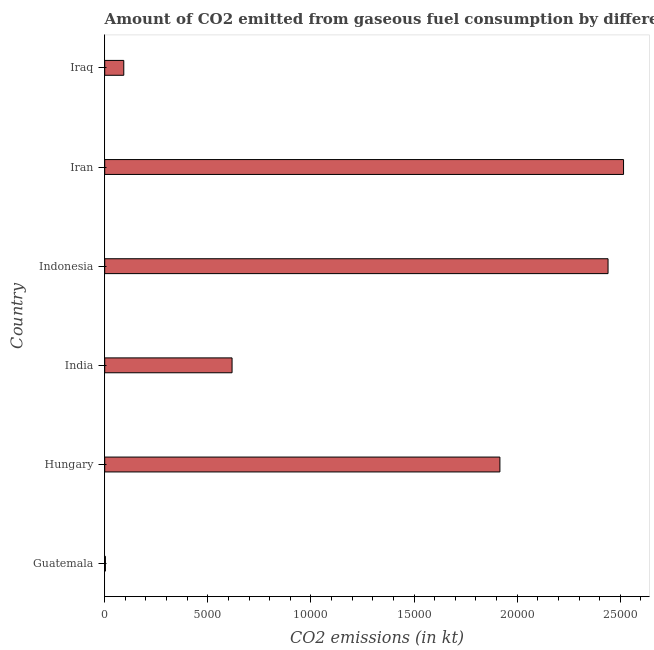Does the graph contain grids?
Provide a short and direct response. No. What is the title of the graph?
Make the answer very short. Amount of CO2 emitted from gaseous fuel consumption by different countries in 1984. What is the label or title of the X-axis?
Offer a very short reply. CO2 emissions (in kt). What is the label or title of the Y-axis?
Your answer should be compact. Country. What is the co2 emissions from gaseous fuel consumption in India?
Your answer should be compact. 6175.23. Across all countries, what is the maximum co2 emissions from gaseous fuel consumption?
Make the answer very short. 2.52e+04. Across all countries, what is the minimum co2 emissions from gaseous fuel consumption?
Keep it short and to the point. 33. In which country was the co2 emissions from gaseous fuel consumption maximum?
Your answer should be very brief. Iran. In which country was the co2 emissions from gaseous fuel consumption minimum?
Ensure brevity in your answer.  Guatemala. What is the sum of the co2 emissions from gaseous fuel consumption?
Provide a succinct answer. 7.59e+04. What is the difference between the co2 emissions from gaseous fuel consumption in Indonesia and Iraq?
Your answer should be compact. 2.35e+04. What is the average co2 emissions from gaseous fuel consumption per country?
Give a very brief answer. 1.26e+04. What is the median co2 emissions from gaseous fuel consumption?
Your answer should be very brief. 1.27e+04. In how many countries, is the co2 emissions from gaseous fuel consumption greater than 1000 kt?
Offer a very short reply. 4. What is the ratio of the co2 emissions from gaseous fuel consumption in Hungary to that in Iran?
Ensure brevity in your answer.  0.76. What is the difference between the highest and the second highest co2 emissions from gaseous fuel consumption?
Offer a terse response. 751.74. What is the difference between the highest and the lowest co2 emissions from gaseous fuel consumption?
Provide a short and direct response. 2.51e+04. In how many countries, is the co2 emissions from gaseous fuel consumption greater than the average co2 emissions from gaseous fuel consumption taken over all countries?
Your response must be concise. 3. How many bars are there?
Give a very brief answer. 6. Are all the bars in the graph horizontal?
Make the answer very short. Yes. How many countries are there in the graph?
Your response must be concise. 6. What is the CO2 emissions (in kt) of Guatemala?
Give a very brief answer. 33. What is the CO2 emissions (in kt) in Hungary?
Provide a succinct answer. 1.92e+04. What is the CO2 emissions (in kt) in India?
Your answer should be compact. 6175.23. What is the CO2 emissions (in kt) of Indonesia?
Your response must be concise. 2.44e+04. What is the CO2 emissions (in kt) of Iran?
Provide a short and direct response. 2.52e+04. What is the CO2 emissions (in kt) of Iraq?
Your response must be concise. 924.08. What is the difference between the CO2 emissions (in kt) in Guatemala and Hungary?
Offer a very short reply. -1.91e+04. What is the difference between the CO2 emissions (in kt) in Guatemala and India?
Make the answer very short. -6142.23. What is the difference between the CO2 emissions (in kt) in Guatemala and Indonesia?
Provide a short and direct response. -2.44e+04. What is the difference between the CO2 emissions (in kt) in Guatemala and Iran?
Your answer should be very brief. -2.51e+04. What is the difference between the CO2 emissions (in kt) in Guatemala and Iraq?
Make the answer very short. -891.08. What is the difference between the CO2 emissions (in kt) in Hungary and India?
Provide a succinct answer. 1.30e+04. What is the difference between the CO2 emissions (in kt) in Hungary and Indonesia?
Keep it short and to the point. -5243.81. What is the difference between the CO2 emissions (in kt) in Hungary and Iran?
Your answer should be very brief. -5995.55. What is the difference between the CO2 emissions (in kt) in Hungary and Iraq?
Offer a terse response. 1.82e+04. What is the difference between the CO2 emissions (in kt) in India and Indonesia?
Your answer should be compact. -1.82e+04. What is the difference between the CO2 emissions (in kt) in India and Iran?
Ensure brevity in your answer.  -1.90e+04. What is the difference between the CO2 emissions (in kt) in India and Iraq?
Give a very brief answer. 5251.14. What is the difference between the CO2 emissions (in kt) in Indonesia and Iran?
Give a very brief answer. -751.74. What is the difference between the CO2 emissions (in kt) in Indonesia and Iraq?
Offer a terse response. 2.35e+04. What is the difference between the CO2 emissions (in kt) in Iran and Iraq?
Your answer should be very brief. 2.42e+04. What is the ratio of the CO2 emissions (in kt) in Guatemala to that in Hungary?
Provide a succinct answer. 0. What is the ratio of the CO2 emissions (in kt) in Guatemala to that in India?
Your answer should be compact. 0.01. What is the ratio of the CO2 emissions (in kt) in Guatemala to that in Iraq?
Provide a succinct answer. 0.04. What is the ratio of the CO2 emissions (in kt) in Hungary to that in India?
Make the answer very short. 3.1. What is the ratio of the CO2 emissions (in kt) in Hungary to that in Indonesia?
Your answer should be very brief. 0.79. What is the ratio of the CO2 emissions (in kt) in Hungary to that in Iran?
Keep it short and to the point. 0.76. What is the ratio of the CO2 emissions (in kt) in Hungary to that in Iraq?
Keep it short and to the point. 20.74. What is the ratio of the CO2 emissions (in kt) in India to that in Indonesia?
Your response must be concise. 0.25. What is the ratio of the CO2 emissions (in kt) in India to that in Iran?
Make the answer very short. 0.24. What is the ratio of the CO2 emissions (in kt) in India to that in Iraq?
Keep it short and to the point. 6.68. What is the ratio of the CO2 emissions (in kt) in Indonesia to that in Iran?
Ensure brevity in your answer.  0.97. What is the ratio of the CO2 emissions (in kt) in Indonesia to that in Iraq?
Ensure brevity in your answer.  26.41. What is the ratio of the CO2 emissions (in kt) in Iran to that in Iraq?
Ensure brevity in your answer.  27.23. 